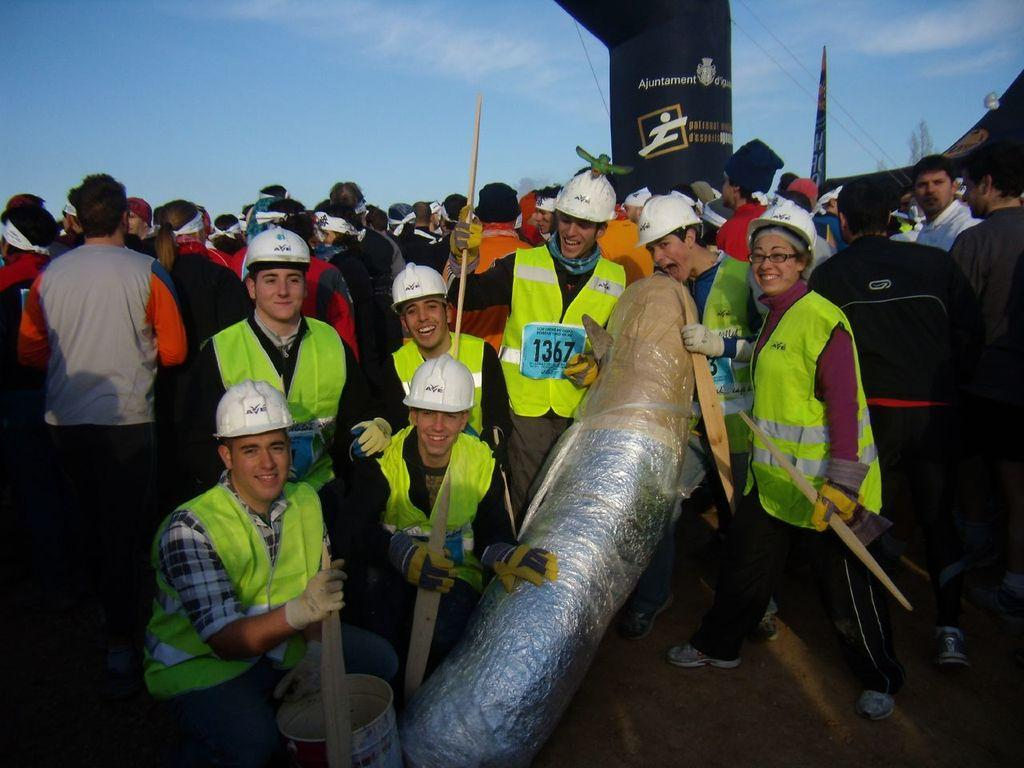What are the people in the image doing? Some people are standing, and some are sitting in the image. What are the people holding in their hands? The people are holding wooden sticks in the image. Can you describe the object in the image? Unfortunately, the facts provided do not give a specific description of the object. What can be seen in the background of the image? The sky and a flag are visible in the background of the image. What is the owner's pet feeling in the image? There is no pet or owner present in the image, so it is not possible to answer this question. 